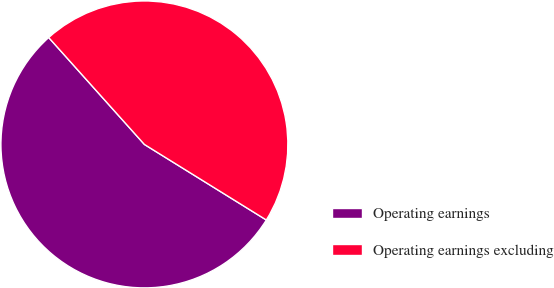Convert chart. <chart><loc_0><loc_0><loc_500><loc_500><pie_chart><fcel>Operating earnings<fcel>Operating earnings excluding<nl><fcel>54.55%<fcel>45.45%<nl></chart> 